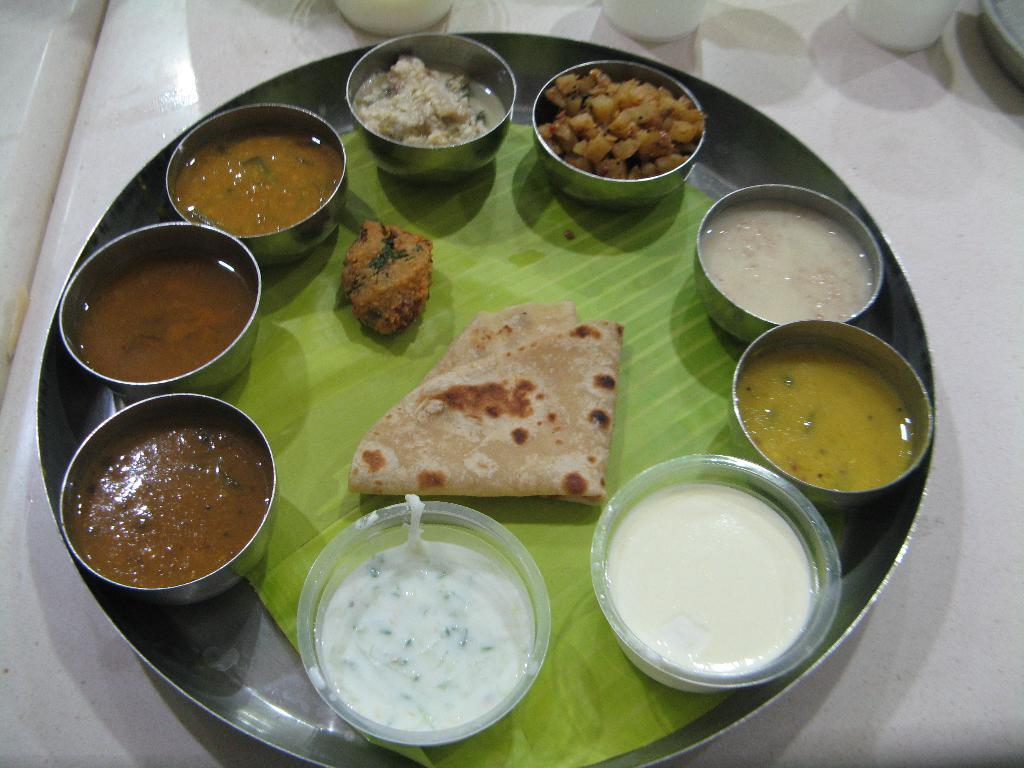What is the main object in the center of the image? There is a plate in the center of the image. Where is the plate located? The plate is on a table. What can be found on the plate? There are many food items on the plate. How many thumbs are visible on the plate in the image? There are no thumbs visible on the plate in the image. Is the image completely quiet, or can any sounds be heard? The image is a still image and does not convey any sounds, so it cannot be described as quiet or not quiet. 